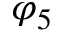Convert formula to latex. <formula><loc_0><loc_0><loc_500><loc_500>\varphi _ { 5 }</formula> 